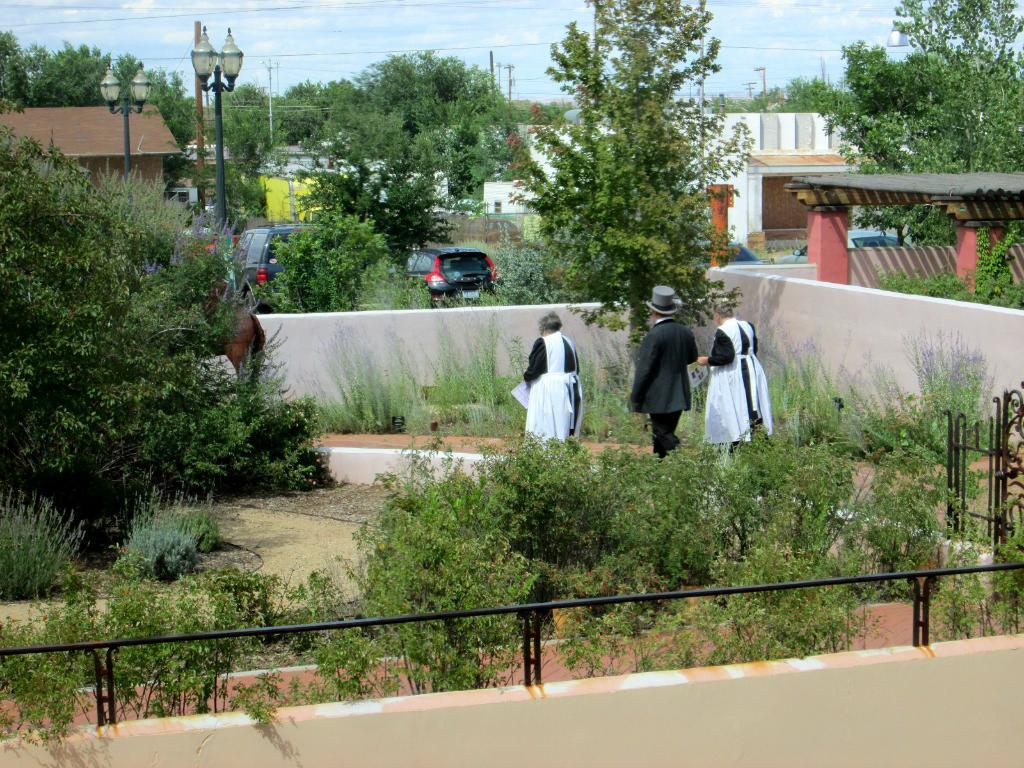What types of living organisms can be seen in the image? Plants and trees are visible in the image. What type of structures can be seen in the image? Walls, buildings, and light poles are visible in the image. What type of transportation is present in the image? Vehicles are present in the image. What type of objects can be seen in the image? Papers, a cap, and some other objects are visible in the image. How many people are in the image? There are three people in the image. What is visible in the background of the image? The sky is visible in the background of the image. What type of lace is being used to decorate the committee meeting in the image? There is no committee meeting or lace present in the image. Can you tell me how many spots are visible on the plants in the image? The provided facts do not mention any spots on the plants, so it cannot be determined from the image. 